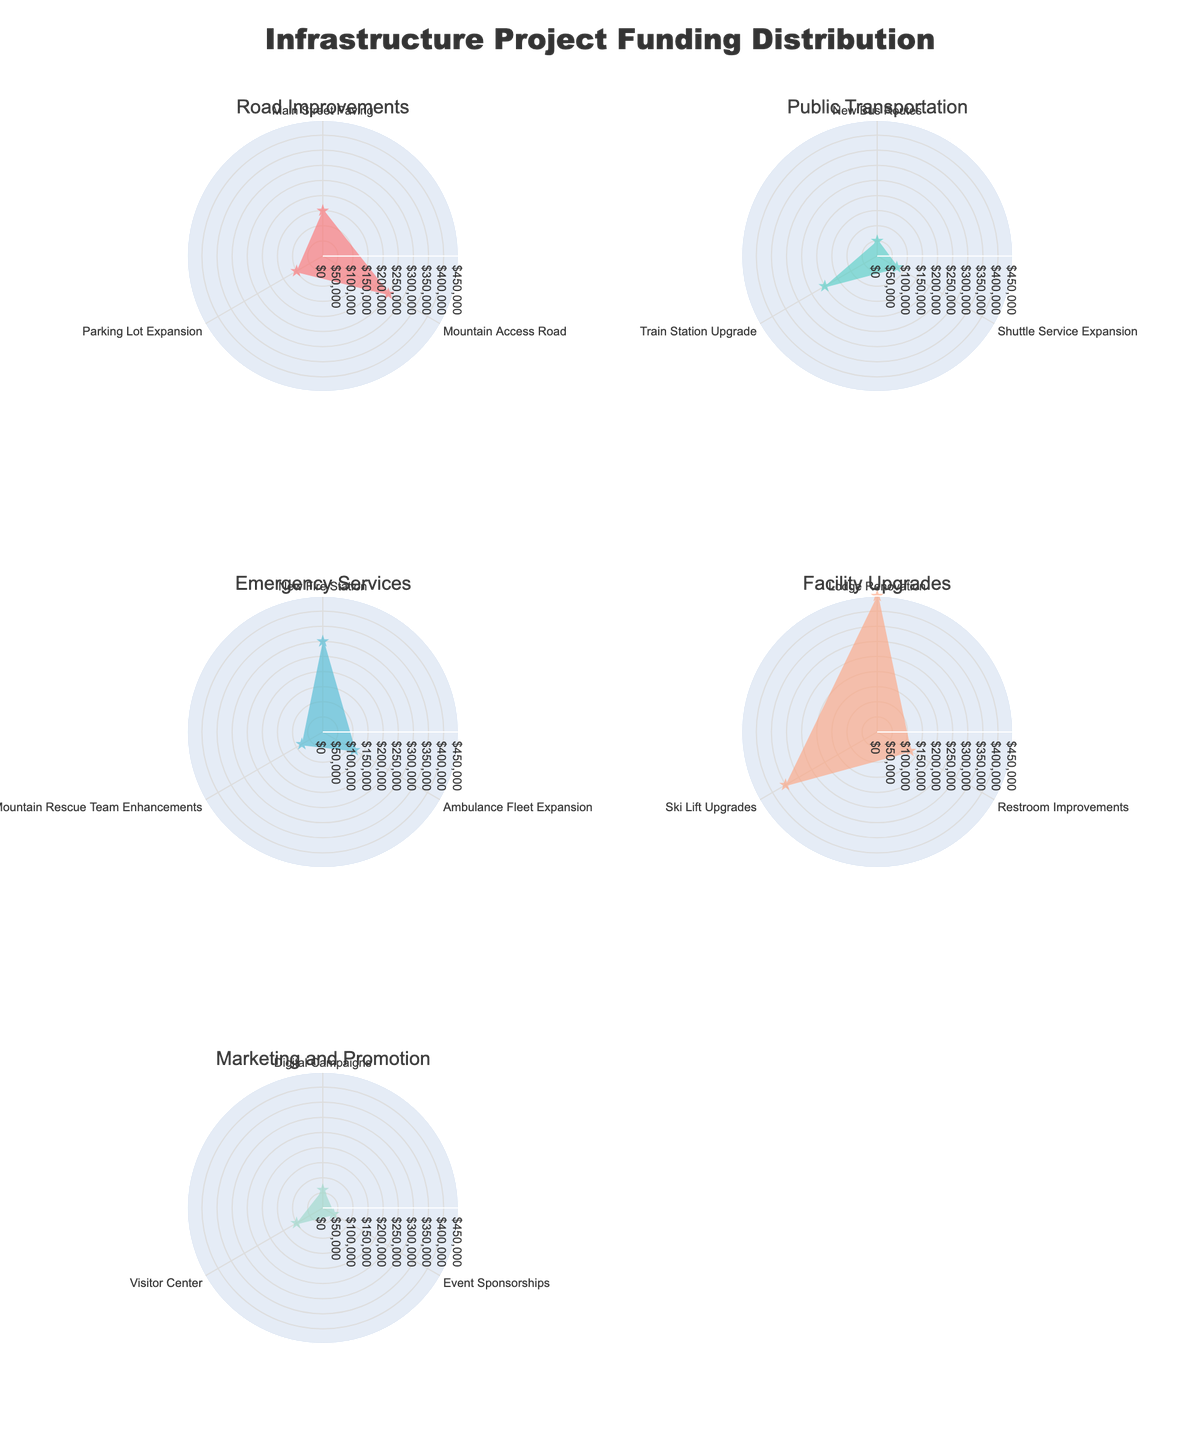What's the title of the figure? The title is usually prominently displayed at the top of the figure for easy identification. The title of this figure is "Infrastructure Project Funding Distribution."
Answer: Infrastructure Project Funding Distribution Which category has the most funding distributed? By observing the radar charts, we can compare the radial extents. The category with the highest funding can be identified by the outermost values. "Facility Upgrades" has the highest radial extent.
Answer: Facility Upgrades How much funding was allocated to Road Improvements? The Road Improvements subplot shows three projects: Main Street Paving, Mountain Access Road, and Parking Lot Expansion. Summing their amounts: 150,000 + 250,000 + 100,000 = 500,000.
Answer: 500,000 What is the largest funded project in Emergency Services? In the Emergency Services subplot, the largest funding is associated with "New Fire Station," which has the highest radial value.
Answer: New Fire Station How does the total funding for Public Transportation compare to Marketing and Promotion? Summing funding for each category: Public Transportation: 50,000 + 75,000 + 200,000 = 325,000 Marketing and Promotion: 60,000 + 40,000 + 100,000 = 200,000 Therefore, Public Transportation has more funding.
Answer: Public Transportation has more funding What is the smallest funded project in Facility Upgrades? In the Facility Upgrades subplot, the smallest funding is associated with "Restroom Improvements," which has the lowest radial value.
Answer: Restroom Improvements Which category has the highest individual project funding and what is the amount? By examining all subplots, we can see that the "Facility Upgrades" category and its "Lodge Renovation" project has the highest individual funding.
Answer: Lodge Renovation, 450,000 Is the combined funding for Emergency Services larger than that for Road Improvements? Summing funding for each category: Emergency Services: 300,000 + 120,000 + 80,000 = 500,000 Road Improvements: 150,000 + 250,000 + 100,000 = 500,000 Therefore, both have equal funding.
Answer: No, they are equal How much more funding was allocated to the Train Station Upgrade than to New Bus Routes? In the Public Transportation subplot, subtracting the funding for "New Bus Routes" from "Train Station Upgrade": 200,000 - 50,000 = 150,000.
Answer: 150,000 Which category's projects have the most uniform distribution of funding? Uniform distribution is indicated by similar radial lengths. The Marketing and Promotion category has relatively uniform funding amounts for its three projects.
Answer: Marketing and Promotion 